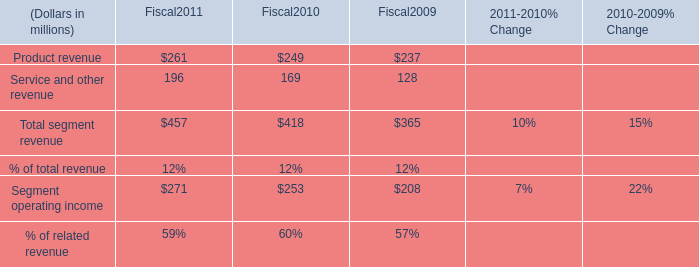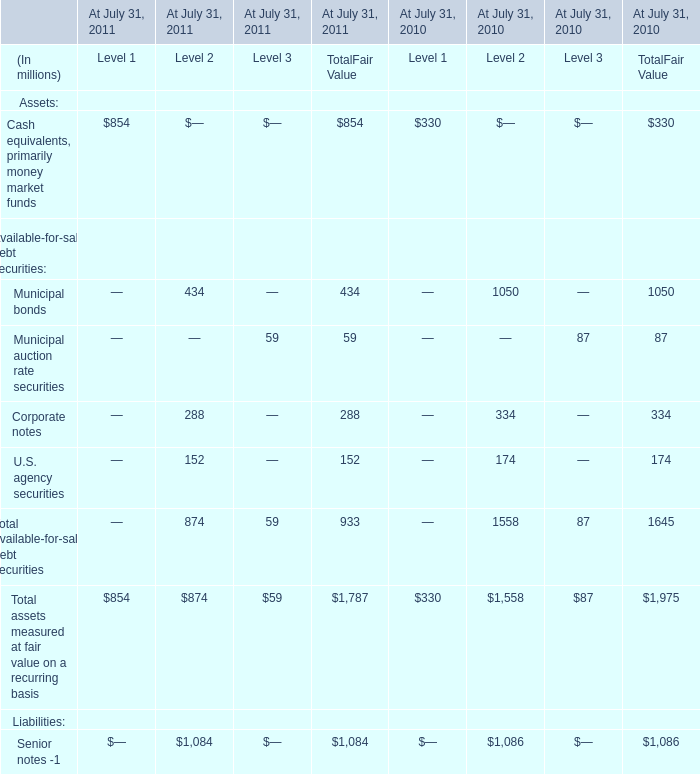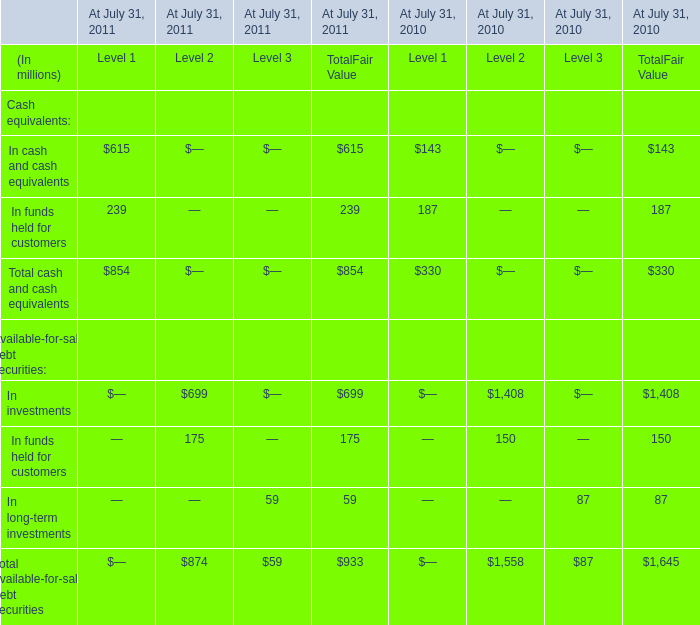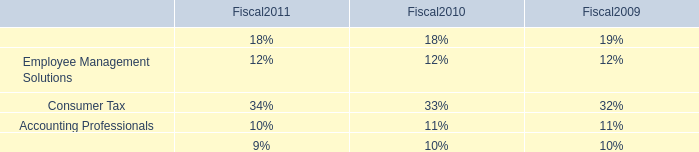In the year with largest amount of Total available-for-sale debt securities, what's the increasing rate of In investments? 
Computations: ((699 - 1408) / 1408)
Answer: -0.50355. 